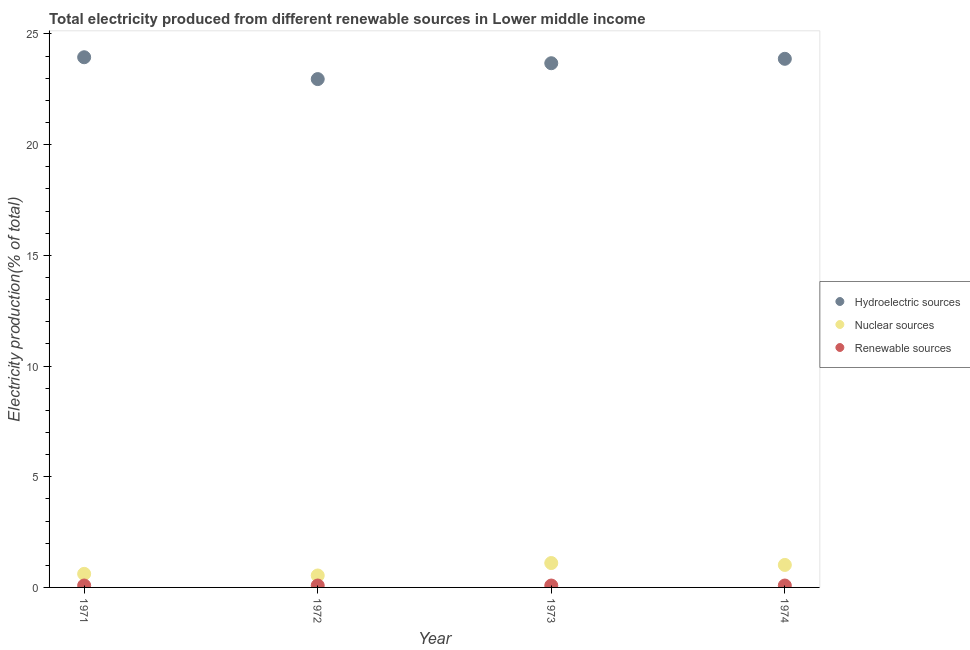How many different coloured dotlines are there?
Keep it short and to the point. 3. What is the percentage of electricity produced by hydroelectric sources in 1971?
Ensure brevity in your answer.  23.95. Across all years, what is the maximum percentage of electricity produced by hydroelectric sources?
Offer a terse response. 23.95. Across all years, what is the minimum percentage of electricity produced by nuclear sources?
Offer a very short reply. 0.54. What is the total percentage of electricity produced by renewable sources in the graph?
Make the answer very short. 0.34. What is the difference between the percentage of electricity produced by nuclear sources in 1971 and that in 1973?
Provide a succinct answer. -0.49. What is the difference between the percentage of electricity produced by nuclear sources in 1972 and the percentage of electricity produced by hydroelectric sources in 1974?
Provide a short and direct response. -23.34. What is the average percentage of electricity produced by hydroelectric sources per year?
Ensure brevity in your answer.  23.62. In the year 1971, what is the difference between the percentage of electricity produced by hydroelectric sources and percentage of electricity produced by nuclear sources?
Ensure brevity in your answer.  23.34. In how many years, is the percentage of electricity produced by hydroelectric sources greater than 24 %?
Offer a very short reply. 0. What is the ratio of the percentage of electricity produced by hydroelectric sources in 1973 to that in 1974?
Offer a terse response. 0.99. Is the percentage of electricity produced by hydroelectric sources in 1971 less than that in 1974?
Make the answer very short. No. Is the difference between the percentage of electricity produced by hydroelectric sources in 1972 and 1974 greater than the difference between the percentage of electricity produced by renewable sources in 1972 and 1974?
Offer a very short reply. No. What is the difference between the highest and the second highest percentage of electricity produced by renewable sources?
Make the answer very short. 0. What is the difference between the highest and the lowest percentage of electricity produced by nuclear sources?
Your response must be concise. 0.56. Is it the case that in every year, the sum of the percentage of electricity produced by hydroelectric sources and percentage of electricity produced by nuclear sources is greater than the percentage of electricity produced by renewable sources?
Provide a succinct answer. Yes. Does the percentage of electricity produced by renewable sources monotonically increase over the years?
Ensure brevity in your answer.  No. Is the percentage of electricity produced by renewable sources strictly less than the percentage of electricity produced by nuclear sources over the years?
Your response must be concise. Yes. How many dotlines are there?
Ensure brevity in your answer.  3. Are the values on the major ticks of Y-axis written in scientific E-notation?
Keep it short and to the point. No. Does the graph contain any zero values?
Make the answer very short. No. Does the graph contain grids?
Your answer should be very brief. No. Where does the legend appear in the graph?
Your answer should be compact. Center right. How many legend labels are there?
Offer a very short reply. 3. How are the legend labels stacked?
Ensure brevity in your answer.  Vertical. What is the title of the graph?
Provide a short and direct response. Total electricity produced from different renewable sources in Lower middle income. What is the Electricity production(% of total) of Hydroelectric sources in 1971?
Offer a terse response. 23.95. What is the Electricity production(% of total) of Nuclear sources in 1971?
Give a very brief answer. 0.61. What is the Electricity production(% of total) in Renewable sources in 1971?
Offer a terse response. 0.09. What is the Electricity production(% of total) in Hydroelectric sources in 1972?
Offer a terse response. 22.96. What is the Electricity production(% of total) in Nuclear sources in 1972?
Provide a succinct answer. 0.54. What is the Electricity production(% of total) in Renewable sources in 1972?
Give a very brief answer. 0.09. What is the Electricity production(% of total) of Hydroelectric sources in 1973?
Your response must be concise. 23.68. What is the Electricity production(% of total) in Nuclear sources in 1973?
Offer a very short reply. 1.1. What is the Electricity production(% of total) in Renewable sources in 1973?
Provide a short and direct response. 0.09. What is the Electricity production(% of total) of Hydroelectric sources in 1974?
Keep it short and to the point. 23.88. What is the Electricity production(% of total) in Nuclear sources in 1974?
Give a very brief answer. 1.02. What is the Electricity production(% of total) of Renewable sources in 1974?
Make the answer very short. 0.09. Across all years, what is the maximum Electricity production(% of total) in Hydroelectric sources?
Your answer should be compact. 23.95. Across all years, what is the maximum Electricity production(% of total) in Nuclear sources?
Your response must be concise. 1.1. Across all years, what is the maximum Electricity production(% of total) of Renewable sources?
Ensure brevity in your answer.  0.09. Across all years, what is the minimum Electricity production(% of total) in Hydroelectric sources?
Give a very brief answer. 22.96. Across all years, what is the minimum Electricity production(% of total) of Nuclear sources?
Provide a short and direct response. 0.54. Across all years, what is the minimum Electricity production(% of total) of Renewable sources?
Provide a short and direct response. 0.09. What is the total Electricity production(% of total) in Hydroelectric sources in the graph?
Provide a succinct answer. 94.47. What is the total Electricity production(% of total) in Nuclear sources in the graph?
Keep it short and to the point. 3.27. What is the total Electricity production(% of total) of Renewable sources in the graph?
Provide a succinct answer. 0.34. What is the difference between the Electricity production(% of total) in Hydroelectric sources in 1971 and that in 1972?
Offer a terse response. 0.99. What is the difference between the Electricity production(% of total) in Nuclear sources in 1971 and that in 1972?
Your answer should be very brief. 0.07. What is the difference between the Electricity production(% of total) of Renewable sources in 1971 and that in 1972?
Provide a short and direct response. 0. What is the difference between the Electricity production(% of total) in Hydroelectric sources in 1971 and that in 1973?
Your answer should be compact. 0.27. What is the difference between the Electricity production(% of total) of Nuclear sources in 1971 and that in 1973?
Provide a short and direct response. -0.49. What is the difference between the Electricity production(% of total) of Renewable sources in 1971 and that in 1973?
Your response must be concise. 0. What is the difference between the Electricity production(% of total) in Hydroelectric sources in 1971 and that in 1974?
Your response must be concise. 0.07. What is the difference between the Electricity production(% of total) of Nuclear sources in 1971 and that in 1974?
Your response must be concise. -0.4. What is the difference between the Electricity production(% of total) in Renewable sources in 1971 and that in 1974?
Provide a succinct answer. 0. What is the difference between the Electricity production(% of total) in Hydroelectric sources in 1972 and that in 1973?
Make the answer very short. -0.72. What is the difference between the Electricity production(% of total) of Nuclear sources in 1972 and that in 1973?
Offer a very short reply. -0.56. What is the difference between the Electricity production(% of total) of Renewable sources in 1972 and that in 1973?
Provide a short and direct response. 0. What is the difference between the Electricity production(% of total) in Hydroelectric sources in 1972 and that in 1974?
Provide a short and direct response. -0.92. What is the difference between the Electricity production(% of total) of Nuclear sources in 1972 and that in 1974?
Your answer should be compact. -0.48. What is the difference between the Electricity production(% of total) in Renewable sources in 1972 and that in 1974?
Ensure brevity in your answer.  0. What is the difference between the Electricity production(% of total) in Hydroelectric sources in 1973 and that in 1974?
Provide a short and direct response. -0.2. What is the difference between the Electricity production(% of total) of Nuclear sources in 1973 and that in 1974?
Give a very brief answer. 0.09. What is the difference between the Electricity production(% of total) in Renewable sources in 1973 and that in 1974?
Provide a succinct answer. -0. What is the difference between the Electricity production(% of total) of Hydroelectric sources in 1971 and the Electricity production(% of total) of Nuclear sources in 1972?
Keep it short and to the point. 23.41. What is the difference between the Electricity production(% of total) in Hydroelectric sources in 1971 and the Electricity production(% of total) in Renewable sources in 1972?
Provide a short and direct response. 23.86. What is the difference between the Electricity production(% of total) in Nuclear sources in 1971 and the Electricity production(% of total) in Renewable sources in 1972?
Your response must be concise. 0.53. What is the difference between the Electricity production(% of total) of Hydroelectric sources in 1971 and the Electricity production(% of total) of Nuclear sources in 1973?
Your answer should be compact. 22.85. What is the difference between the Electricity production(% of total) in Hydroelectric sources in 1971 and the Electricity production(% of total) in Renewable sources in 1973?
Your answer should be very brief. 23.86. What is the difference between the Electricity production(% of total) of Nuclear sources in 1971 and the Electricity production(% of total) of Renewable sources in 1973?
Your response must be concise. 0.53. What is the difference between the Electricity production(% of total) of Hydroelectric sources in 1971 and the Electricity production(% of total) of Nuclear sources in 1974?
Give a very brief answer. 22.93. What is the difference between the Electricity production(% of total) in Hydroelectric sources in 1971 and the Electricity production(% of total) in Renewable sources in 1974?
Make the answer very short. 23.86. What is the difference between the Electricity production(% of total) of Nuclear sources in 1971 and the Electricity production(% of total) of Renewable sources in 1974?
Ensure brevity in your answer.  0.53. What is the difference between the Electricity production(% of total) of Hydroelectric sources in 1972 and the Electricity production(% of total) of Nuclear sources in 1973?
Your answer should be compact. 21.86. What is the difference between the Electricity production(% of total) of Hydroelectric sources in 1972 and the Electricity production(% of total) of Renewable sources in 1973?
Offer a very short reply. 22.88. What is the difference between the Electricity production(% of total) of Nuclear sources in 1972 and the Electricity production(% of total) of Renewable sources in 1973?
Provide a short and direct response. 0.45. What is the difference between the Electricity production(% of total) in Hydroelectric sources in 1972 and the Electricity production(% of total) in Nuclear sources in 1974?
Your answer should be very brief. 21.95. What is the difference between the Electricity production(% of total) of Hydroelectric sources in 1972 and the Electricity production(% of total) of Renewable sources in 1974?
Your answer should be very brief. 22.88. What is the difference between the Electricity production(% of total) in Nuclear sources in 1972 and the Electricity production(% of total) in Renewable sources in 1974?
Your answer should be very brief. 0.45. What is the difference between the Electricity production(% of total) of Hydroelectric sources in 1973 and the Electricity production(% of total) of Nuclear sources in 1974?
Keep it short and to the point. 22.66. What is the difference between the Electricity production(% of total) of Hydroelectric sources in 1973 and the Electricity production(% of total) of Renewable sources in 1974?
Offer a terse response. 23.59. What is the difference between the Electricity production(% of total) in Nuclear sources in 1973 and the Electricity production(% of total) in Renewable sources in 1974?
Your answer should be very brief. 1.02. What is the average Electricity production(% of total) of Hydroelectric sources per year?
Your response must be concise. 23.62. What is the average Electricity production(% of total) in Nuclear sources per year?
Offer a terse response. 0.82. What is the average Electricity production(% of total) in Renewable sources per year?
Your response must be concise. 0.09. In the year 1971, what is the difference between the Electricity production(% of total) in Hydroelectric sources and Electricity production(% of total) in Nuclear sources?
Give a very brief answer. 23.34. In the year 1971, what is the difference between the Electricity production(% of total) of Hydroelectric sources and Electricity production(% of total) of Renewable sources?
Your response must be concise. 23.86. In the year 1971, what is the difference between the Electricity production(% of total) of Nuclear sources and Electricity production(% of total) of Renewable sources?
Ensure brevity in your answer.  0.53. In the year 1972, what is the difference between the Electricity production(% of total) in Hydroelectric sources and Electricity production(% of total) in Nuclear sources?
Your answer should be compact. 22.42. In the year 1972, what is the difference between the Electricity production(% of total) of Hydroelectric sources and Electricity production(% of total) of Renewable sources?
Ensure brevity in your answer.  22.88. In the year 1972, what is the difference between the Electricity production(% of total) of Nuclear sources and Electricity production(% of total) of Renewable sources?
Offer a very short reply. 0.45. In the year 1973, what is the difference between the Electricity production(% of total) of Hydroelectric sources and Electricity production(% of total) of Nuclear sources?
Offer a very short reply. 22.58. In the year 1973, what is the difference between the Electricity production(% of total) in Hydroelectric sources and Electricity production(% of total) in Renewable sources?
Your response must be concise. 23.59. In the year 1973, what is the difference between the Electricity production(% of total) in Nuclear sources and Electricity production(% of total) in Renewable sources?
Offer a terse response. 1.02. In the year 1974, what is the difference between the Electricity production(% of total) of Hydroelectric sources and Electricity production(% of total) of Nuclear sources?
Provide a succinct answer. 22.86. In the year 1974, what is the difference between the Electricity production(% of total) in Hydroelectric sources and Electricity production(% of total) in Renewable sources?
Provide a short and direct response. 23.79. In the year 1974, what is the difference between the Electricity production(% of total) in Nuclear sources and Electricity production(% of total) in Renewable sources?
Provide a short and direct response. 0.93. What is the ratio of the Electricity production(% of total) in Hydroelectric sources in 1971 to that in 1972?
Provide a short and direct response. 1.04. What is the ratio of the Electricity production(% of total) in Nuclear sources in 1971 to that in 1972?
Make the answer very short. 1.14. What is the ratio of the Electricity production(% of total) of Renewable sources in 1971 to that in 1972?
Give a very brief answer. 1.01. What is the ratio of the Electricity production(% of total) of Hydroelectric sources in 1971 to that in 1973?
Provide a short and direct response. 1.01. What is the ratio of the Electricity production(% of total) of Nuclear sources in 1971 to that in 1973?
Your answer should be very brief. 0.56. What is the ratio of the Electricity production(% of total) in Renewable sources in 1971 to that in 1973?
Your answer should be compact. 1.02. What is the ratio of the Electricity production(% of total) of Nuclear sources in 1971 to that in 1974?
Your answer should be compact. 0.6. What is the ratio of the Electricity production(% of total) of Renewable sources in 1971 to that in 1974?
Offer a terse response. 1.02. What is the ratio of the Electricity production(% of total) in Hydroelectric sources in 1972 to that in 1973?
Provide a short and direct response. 0.97. What is the ratio of the Electricity production(% of total) of Nuclear sources in 1972 to that in 1973?
Keep it short and to the point. 0.49. What is the ratio of the Electricity production(% of total) of Renewable sources in 1972 to that in 1973?
Your answer should be compact. 1.01. What is the ratio of the Electricity production(% of total) of Hydroelectric sources in 1972 to that in 1974?
Offer a terse response. 0.96. What is the ratio of the Electricity production(% of total) in Nuclear sources in 1972 to that in 1974?
Keep it short and to the point. 0.53. What is the ratio of the Electricity production(% of total) of Nuclear sources in 1973 to that in 1974?
Ensure brevity in your answer.  1.08. What is the difference between the highest and the second highest Electricity production(% of total) of Hydroelectric sources?
Offer a terse response. 0.07. What is the difference between the highest and the second highest Electricity production(% of total) of Nuclear sources?
Your answer should be very brief. 0.09. What is the difference between the highest and the second highest Electricity production(% of total) of Renewable sources?
Keep it short and to the point. 0. What is the difference between the highest and the lowest Electricity production(% of total) in Hydroelectric sources?
Offer a very short reply. 0.99. What is the difference between the highest and the lowest Electricity production(% of total) in Nuclear sources?
Keep it short and to the point. 0.56. What is the difference between the highest and the lowest Electricity production(% of total) of Renewable sources?
Your response must be concise. 0. 